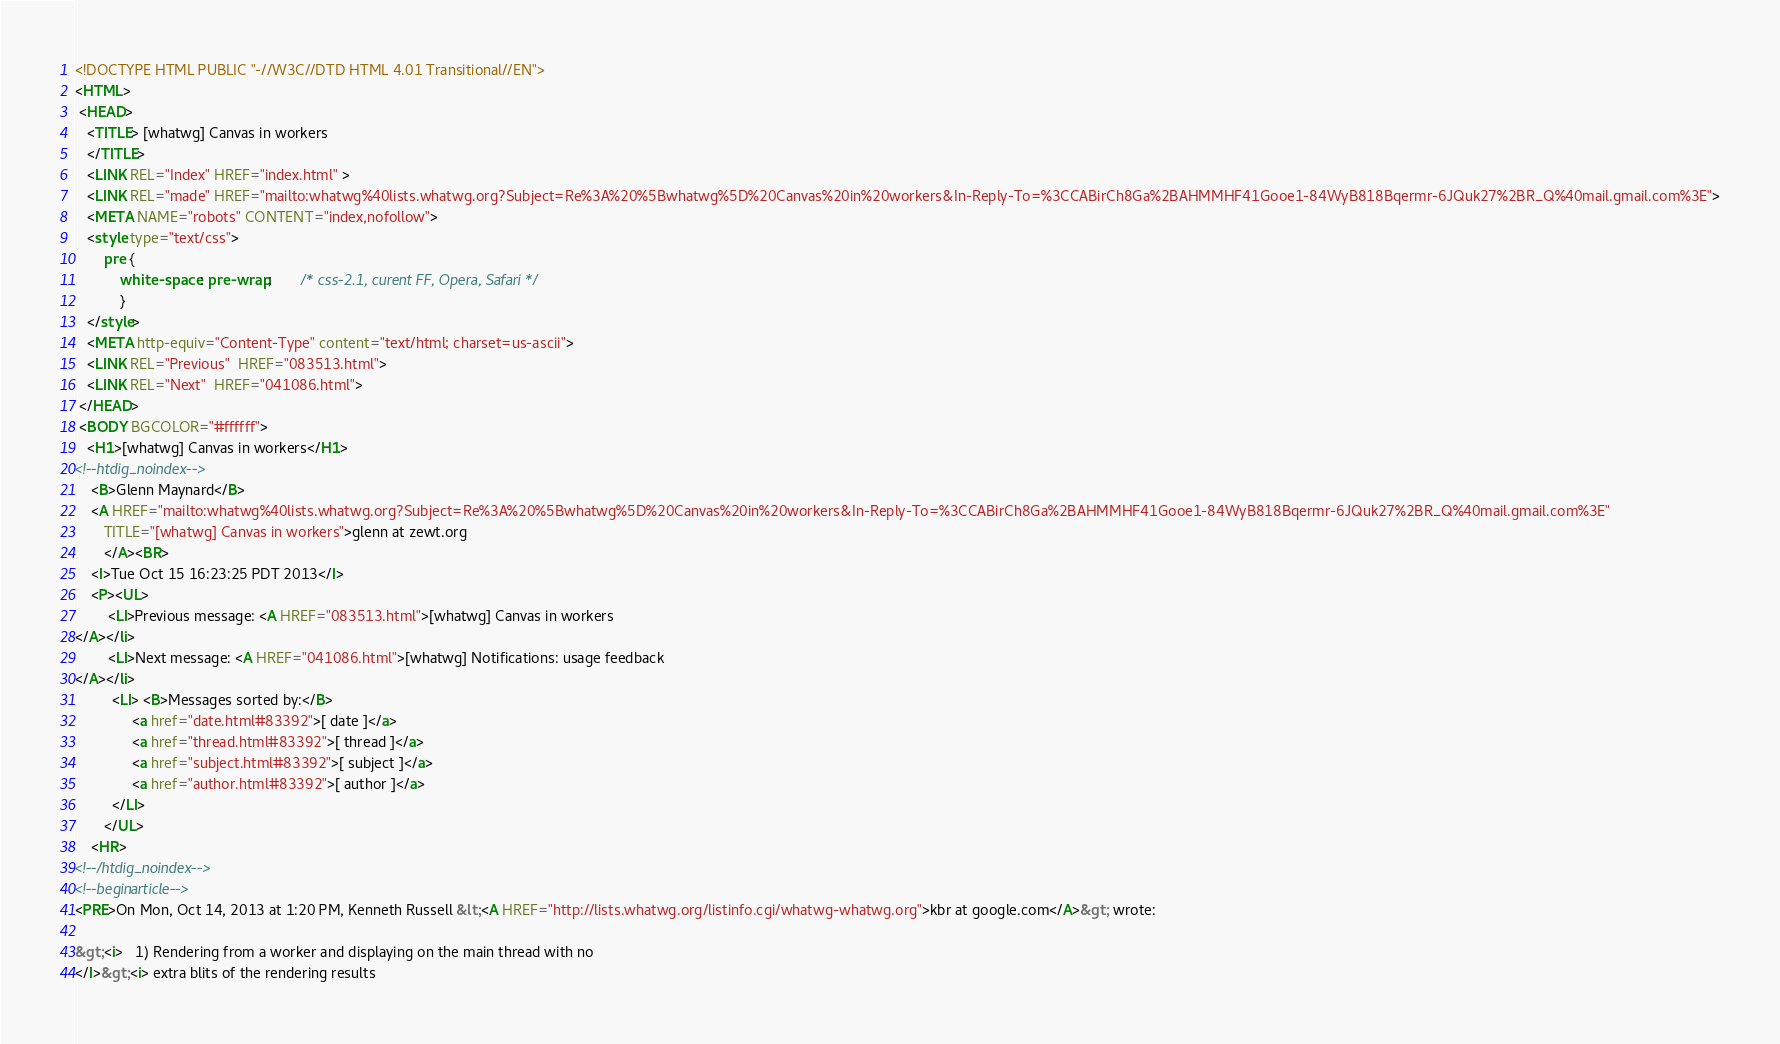Convert code to text. <code><loc_0><loc_0><loc_500><loc_500><_HTML_><!DOCTYPE HTML PUBLIC "-//W3C//DTD HTML 4.01 Transitional//EN">
<HTML>
 <HEAD>
   <TITLE> [whatwg] Canvas in workers
   </TITLE>
   <LINK REL="Index" HREF="index.html" >
   <LINK REL="made" HREF="mailto:whatwg%40lists.whatwg.org?Subject=Re%3A%20%5Bwhatwg%5D%20Canvas%20in%20workers&In-Reply-To=%3CCABirCh8Ga%2BAHMMHF41Gooe1-84WyB818Bqermr-6JQuk27%2BR_Q%40mail.gmail.com%3E">
   <META NAME="robots" CONTENT="index,nofollow">
   <style type="text/css">
       pre {
           white-space: pre-wrap;       /* css-2.1, curent FF, Opera, Safari */
           }
   </style>
   <META http-equiv="Content-Type" content="text/html; charset=us-ascii">
   <LINK REL="Previous"  HREF="083513.html">
   <LINK REL="Next"  HREF="041086.html">
 </HEAD>
 <BODY BGCOLOR="#ffffff">
   <H1>[whatwg] Canvas in workers</H1>
<!--htdig_noindex-->
    <B>Glenn Maynard</B> 
    <A HREF="mailto:whatwg%40lists.whatwg.org?Subject=Re%3A%20%5Bwhatwg%5D%20Canvas%20in%20workers&In-Reply-To=%3CCABirCh8Ga%2BAHMMHF41Gooe1-84WyB818Bqermr-6JQuk27%2BR_Q%40mail.gmail.com%3E"
       TITLE="[whatwg] Canvas in workers">glenn at zewt.org
       </A><BR>
    <I>Tue Oct 15 16:23:25 PDT 2013</I>
    <P><UL>
        <LI>Previous message: <A HREF="083513.html">[whatwg] Canvas in workers
</A></li>
        <LI>Next message: <A HREF="041086.html">[whatwg] Notifications: usage feedback
</A></li>
         <LI> <B>Messages sorted by:</B> 
              <a href="date.html#83392">[ date ]</a>
              <a href="thread.html#83392">[ thread ]</a>
              <a href="subject.html#83392">[ subject ]</a>
              <a href="author.html#83392">[ author ]</a>
         </LI>
       </UL>
    <HR>  
<!--/htdig_noindex-->
<!--beginarticle-->
<PRE>On Mon, Oct 14, 2013 at 1:20 PM, Kenneth Russell &lt;<A HREF="http://lists.whatwg.org/listinfo.cgi/whatwg-whatwg.org">kbr at google.com</A>&gt; wrote:

&gt;<i>   1) Rendering from a worker and displaying on the main thread with no
</I>&gt;<i> extra blits of the rendering results</code> 